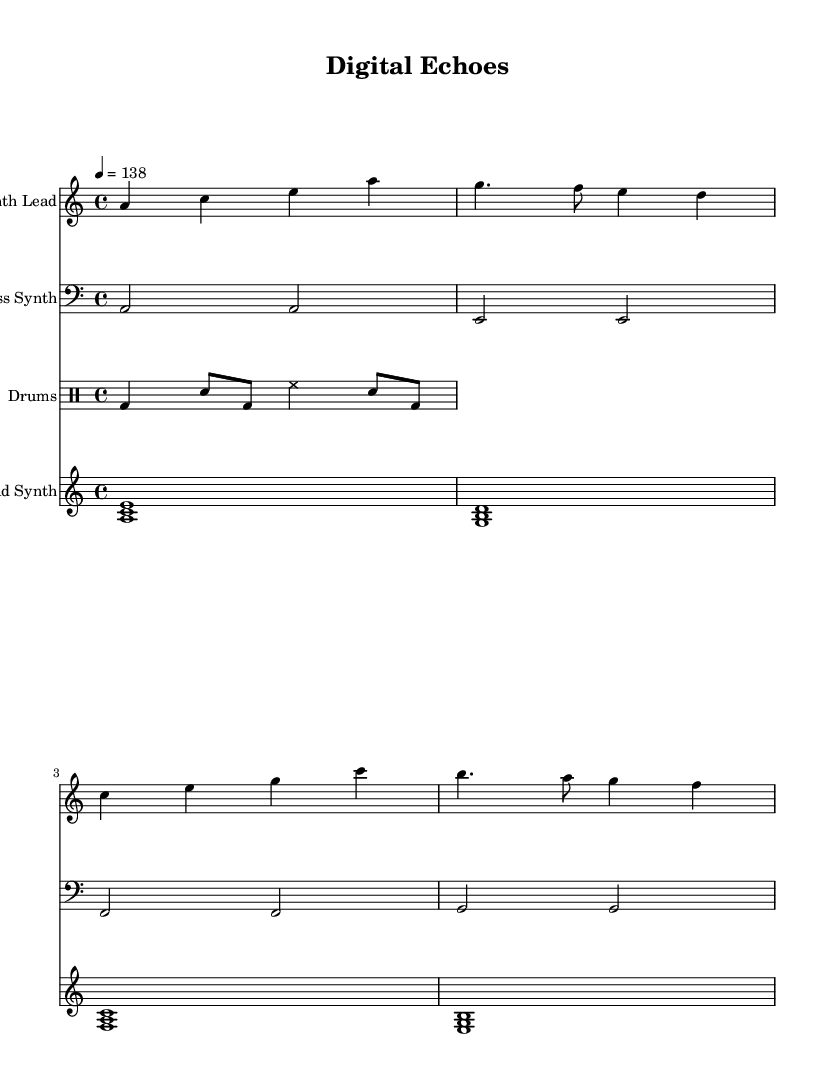What is the key signature of this music? The key signature is indicated at the beginning of the music sheet with one sharp and is associated with the note A.
Answer: A minor What is the time signature of the piece? The time signature is noted at the beginning of the music sheet with two stacked numbers, indicating how many beats are in each measure and what note value is counted as a beat. Here, it is 4 over 4.
Answer: 4/4 What is the tempo marking for this dance piece? The tempo is marked at the beginning of the score with a number indicating beats per minute (BPM), which shows how fast the piece should be played. Here it indicates a tempo of 138.
Answer: 138 How many measures are there in the Synth Lead part? To determine the number of measures, count the segments separated by vertical lines in the Synth Lead staff; each segment represents one measure. There are four measures present.
Answer: 4 Which part is played in the bass clef? The bass clef is generally used for lower-pitched instruments, and in this score, the bass synth is the part indicated beneath the clef symbol.
Answer: Bass Synth What is the primary theme discussed in the lyrics? The lyrics of the piece emphasize the decline of privacy in the digital information age, as expressed in phrases like "privacy fades" and "secrets are sold."
Answer: Erosion of privacy What types of synthesized sounds are used in this piece? By examining the parts listed, we identify several synthesized components, including the synth lead, bass synth, and pad synth, each contributing to the electronic texture of the piece.
Answer: Synth Lead, Bass Synth, Pad Synth 